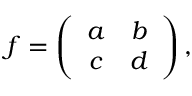<formula> <loc_0><loc_0><loc_500><loc_500>f = \left ( \begin{array} { c c } { a } & { b } \\ { c } & { d } \end{array} \right ) ,</formula> 